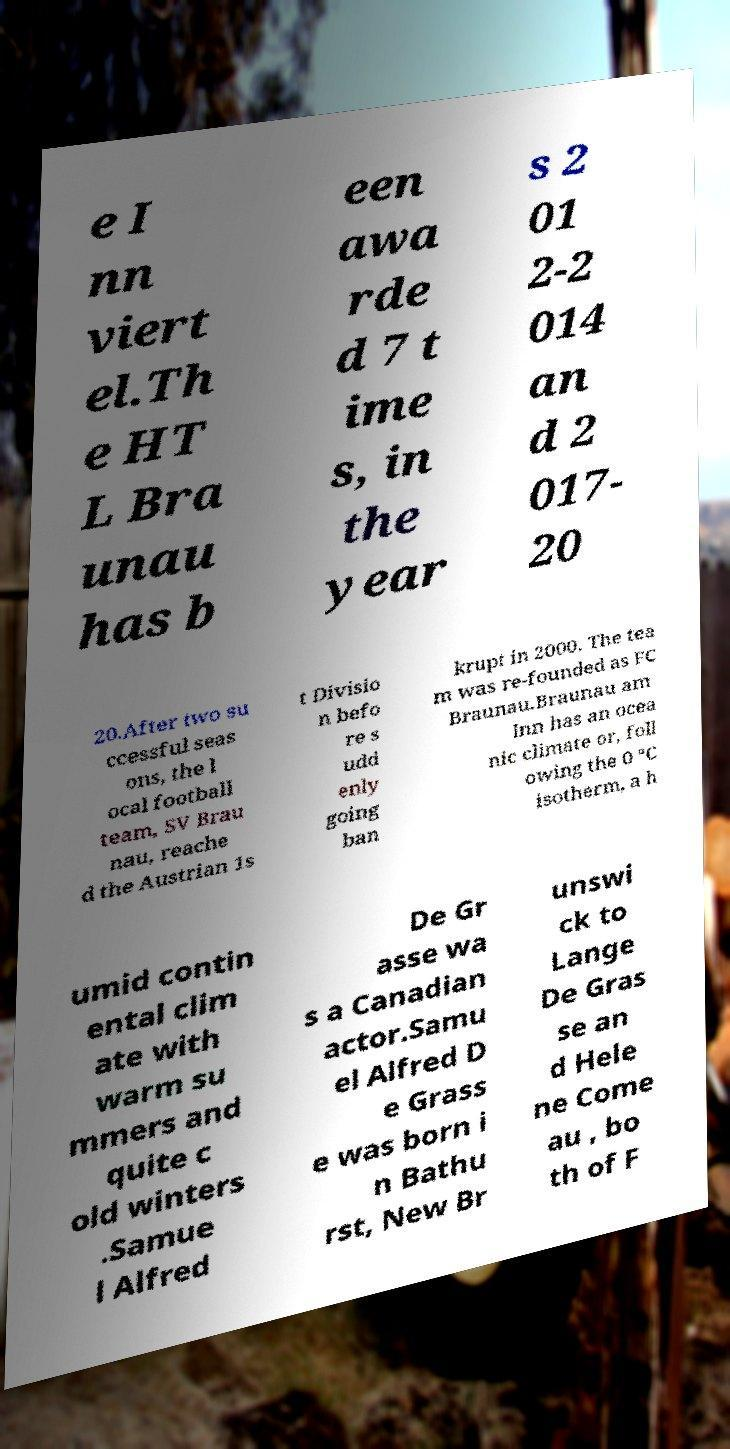Can you read and provide the text displayed in the image?This photo seems to have some interesting text. Can you extract and type it out for me? e I nn viert el.Th e HT L Bra unau has b een awa rde d 7 t ime s, in the year s 2 01 2-2 014 an d 2 017- 20 20.After two su ccessful seas ons, the l ocal football team, SV Brau nau, reache d the Austrian 1s t Divisio n befo re s udd enly going ban krupt in 2000. The tea m was re-founded as FC Braunau.Braunau am Inn has an ocea nic climate or, foll owing the 0 °C isotherm, a h umid contin ental clim ate with warm su mmers and quite c old winters .Samue l Alfred De Gr asse wa s a Canadian actor.Samu el Alfred D e Grass e was born i n Bathu rst, New Br unswi ck to Lange De Gras se an d Hele ne Come au , bo th of F 